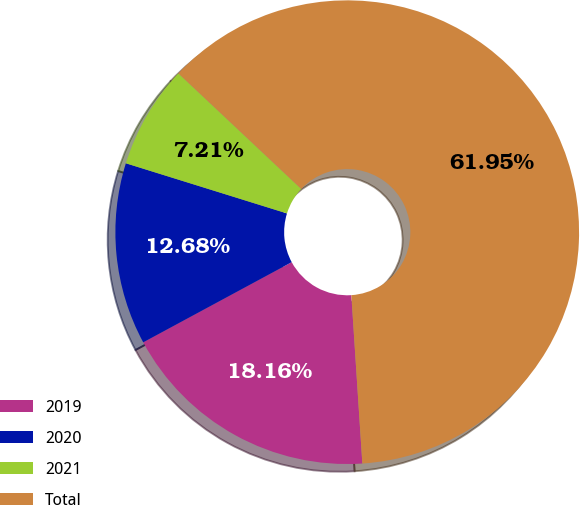<chart> <loc_0><loc_0><loc_500><loc_500><pie_chart><fcel>2019<fcel>2020<fcel>2021<fcel>Total<nl><fcel>18.16%<fcel>12.68%<fcel>7.21%<fcel>61.95%<nl></chart> 